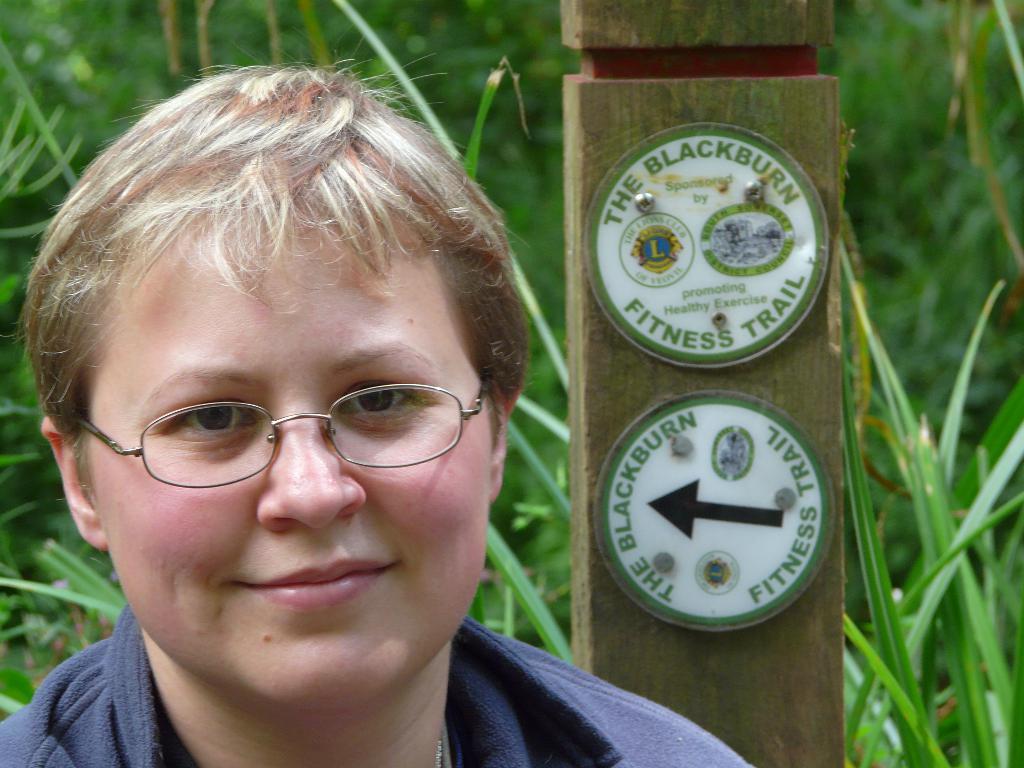Can you describe this image briefly? In this picture I can see there is a person standing and smiling and in the backdrop I can see there is a wooden plank and there is grass. 